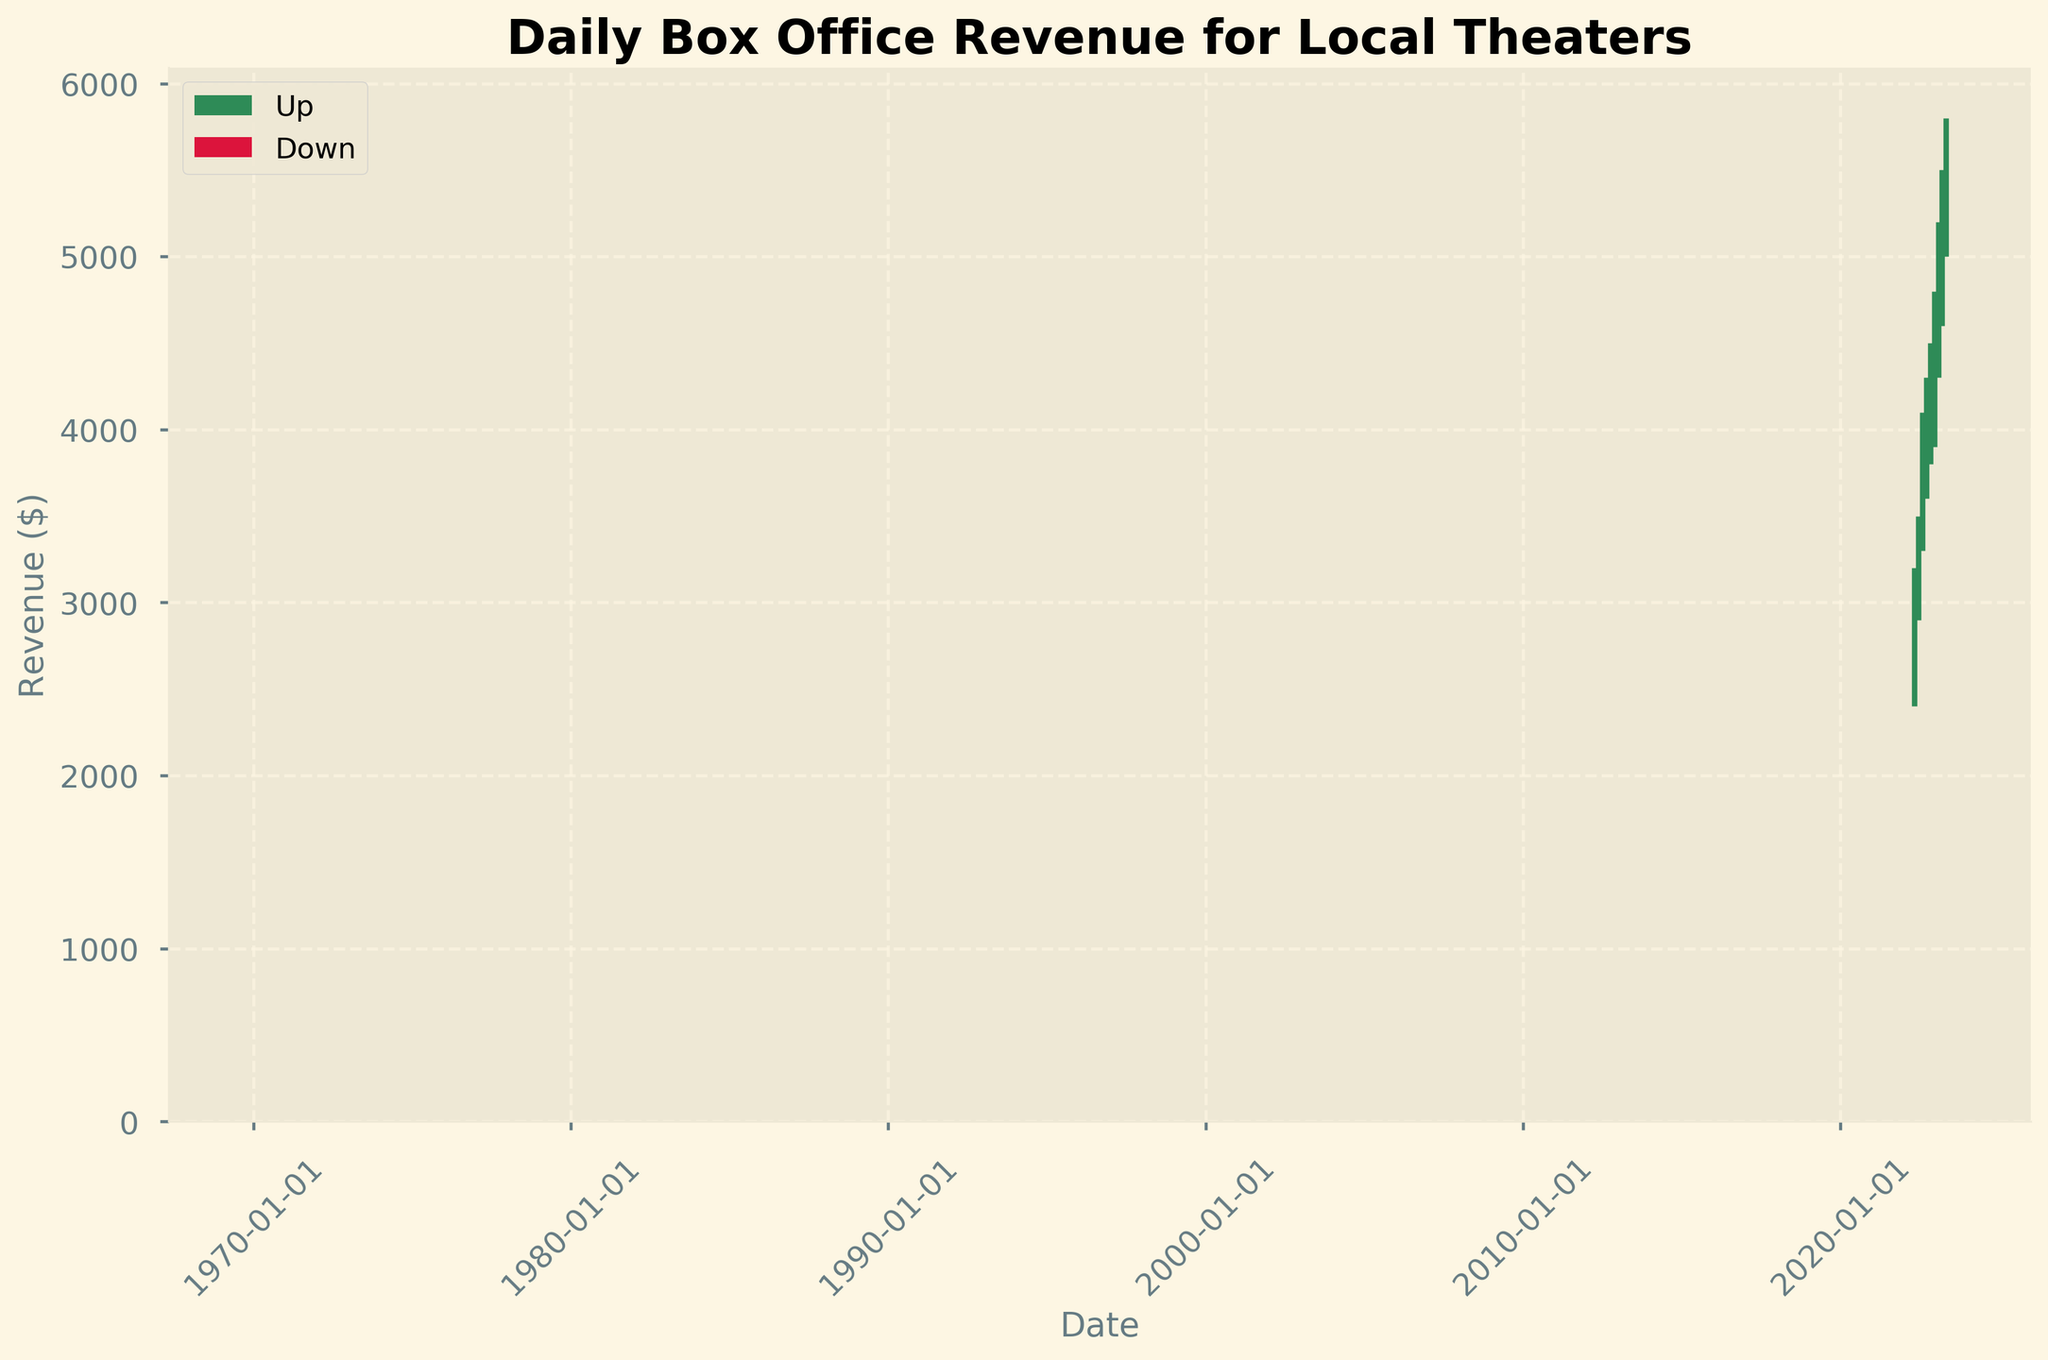What is the title of the plot? The title is usually displayed at the top of the plot and indicates what the data represents. Here, the title is "Daily Box Office Revenue for Local Theaters."
Answer: Daily Box Office Revenue for Local Theaters What does the x-axis represent? The x-axis shows the time dimension, which, based on the labels and format, seems to represent the date.
Answer: Date What colors are used to depict up and down days? In the figure, up days are indicated by one color and down days by another. Up days are shown in seagreen and down days in crimson.
Answer: Seagreen and crimson How many data points are plotted in the figure? Each bar represents a data point, and counting these bars will give the total number of data points. In this case, there are 9 data points.
Answer: 9 On which date is the highest daily revenue recorded, and what is the value? To find the highest daily revenue, we need to look at the high points of each bar. The highest value is 5800 on April 29, 2023.
Answer: April 29, 2023; 5800 Which month shows the highest increase in revenue from open to close? Revenue increase is represented by the green bars. The longest green bar, which indicates the highest increase from open to close, is seen in April 2023. The revenue increase from open (5200) to close (5600) is 400.
Answer: April 2023 What is the average daily closing revenue over the displayed period? Summing up all the closing revenues and dividing by the number of data points: (3000 + 3400 + 3900 + 4100 + 4200 + 4600 + 5000 + 5300 + 5600) / 9 = 39000 / 9 ≈ 4333.
Answer: 4333 Which date has the smallest range between high and low values for the day, and what is the range? We need to find the smallest difference between the high and low values. The smallest range is on October 29, 2022: 4500 - 3800 = 700.
Answer: October 29, 2022; 700 Compare the closing revenue on May 1, 2022, and March 14, 2023. Which date had a higher closing revenue? The closing revenue for May 1, 2022, is 3000, and for March 14, 2023, it is 5300. March 14, 2023, has a higher closing revenue.
Answer: March 14, 2023 